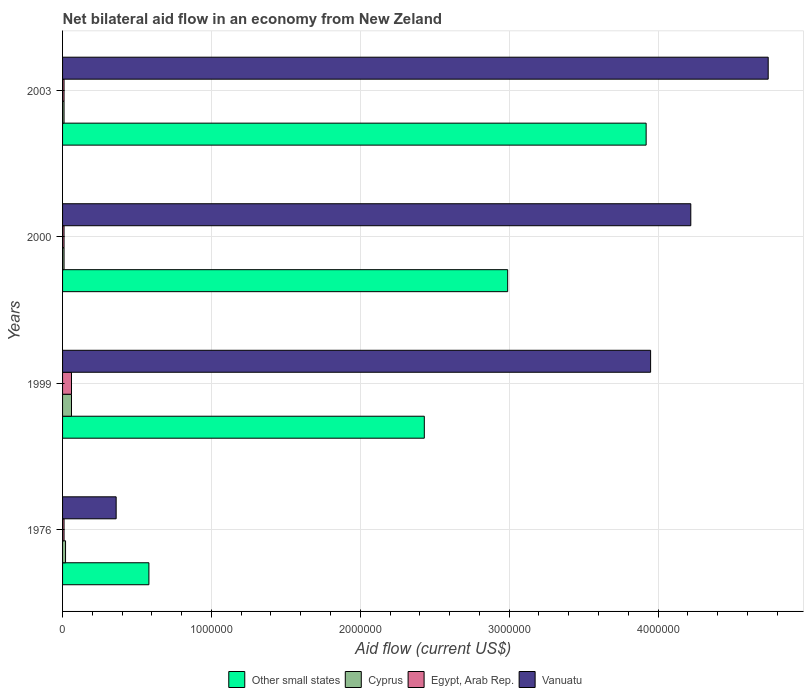How many groups of bars are there?
Provide a succinct answer. 4. Are the number of bars on each tick of the Y-axis equal?
Give a very brief answer. Yes. What is the net bilateral aid flow in Cyprus in 1976?
Provide a short and direct response. 2.00e+04. In which year was the net bilateral aid flow in Vanuatu minimum?
Provide a short and direct response. 1976. What is the difference between the net bilateral aid flow in Other small states in 1976 and that in 2003?
Your answer should be compact. -3.34e+06. What is the difference between the net bilateral aid flow in Cyprus in 1999 and the net bilateral aid flow in Other small states in 2003?
Your response must be concise. -3.86e+06. What is the average net bilateral aid flow in Cyprus per year?
Ensure brevity in your answer.  2.50e+04. In the year 2003, what is the difference between the net bilateral aid flow in Vanuatu and net bilateral aid flow in Cyprus?
Offer a very short reply. 4.73e+06. In how many years, is the net bilateral aid flow in Other small states greater than 4600000 US$?
Ensure brevity in your answer.  0. What is the ratio of the net bilateral aid flow in Egypt, Arab Rep. in 1976 to that in 1999?
Ensure brevity in your answer.  0.17. What is the difference between the highest and the second highest net bilateral aid flow in Cyprus?
Your response must be concise. 4.00e+04. What does the 3rd bar from the top in 2000 represents?
Your answer should be very brief. Cyprus. What does the 4th bar from the bottom in 2000 represents?
Offer a terse response. Vanuatu. Is it the case that in every year, the sum of the net bilateral aid flow in Egypt, Arab Rep. and net bilateral aid flow in Cyprus is greater than the net bilateral aid flow in Other small states?
Keep it short and to the point. No. How many years are there in the graph?
Keep it short and to the point. 4. What is the difference between two consecutive major ticks on the X-axis?
Ensure brevity in your answer.  1.00e+06. Are the values on the major ticks of X-axis written in scientific E-notation?
Offer a terse response. No. Does the graph contain grids?
Give a very brief answer. Yes. How are the legend labels stacked?
Your answer should be very brief. Horizontal. What is the title of the graph?
Make the answer very short. Net bilateral aid flow in an economy from New Zeland. What is the label or title of the X-axis?
Your answer should be very brief. Aid flow (current US$). What is the Aid flow (current US$) in Other small states in 1976?
Provide a succinct answer. 5.80e+05. What is the Aid flow (current US$) in Egypt, Arab Rep. in 1976?
Provide a succinct answer. 10000. What is the Aid flow (current US$) of Vanuatu in 1976?
Make the answer very short. 3.60e+05. What is the Aid flow (current US$) of Other small states in 1999?
Ensure brevity in your answer.  2.43e+06. What is the Aid flow (current US$) in Vanuatu in 1999?
Offer a terse response. 3.95e+06. What is the Aid flow (current US$) in Other small states in 2000?
Give a very brief answer. 2.99e+06. What is the Aid flow (current US$) of Cyprus in 2000?
Keep it short and to the point. 10000. What is the Aid flow (current US$) in Egypt, Arab Rep. in 2000?
Offer a terse response. 10000. What is the Aid flow (current US$) of Vanuatu in 2000?
Ensure brevity in your answer.  4.22e+06. What is the Aid flow (current US$) in Other small states in 2003?
Your answer should be compact. 3.92e+06. What is the Aid flow (current US$) of Cyprus in 2003?
Give a very brief answer. 10000. What is the Aid flow (current US$) in Egypt, Arab Rep. in 2003?
Provide a succinct answer. 10000. What is the Aid flow (current US$) in Vanuatu in 2003?
Ensure brevity in your answer.  4.74e+06. Across all years, what is the maximum Aid flow (current US$) in Other small states?
Keep it short and to the point. 3.92e+06. Across all years, what is the maximum Aid flow (current US$) of Cyprus?
Give a very brief answer. 6.00e+04. Across all years, what is the maximum Aid flow (current US$) in Vanuatu?
Make the answer very short. 4.74e+06. Across all years, what is the minimum Aid flow (current US$) in Other small states?
Ensure brevity in your answer.  5.80e+05. Across all years, what is the minimum Aid flow (current US$) in Vanuatu?
Offer a terse response. 3.60e+05. What is the total Aid flow (current US$) in Other small states in the graph?
Your response must be concise. 9.92e+06. What is the total Aid flow (current US$) in Egypt, Arab Rep. in the graph?
Make the answer very short. 9.00e+04. What is the total Aid flow (current US$) of Vanuatu in the graph?
Ensure brevity in your answer.  1.33e+07. What is the difference between the Aid flow (current US$) of Other small states in 1976 and that in 1999?
Make the answer very short. -1.85e+06. What is the difference between the Aid flow (current US$) of Vanuatu in 1976 and that in 1999?
Offer a terse response. -3.59e+06. What is the difference between the Aid flow (current US$) of Other small states in 1976 and that in 2000?
Offer a very short reply. -2.41e+06. What is the difference between the Aid flow (current US$) in Egypt, Arab Rep. in 1976 and that in 2000?
Make the answer very short. 0. What is the difference between the Aid flow (current US$) of Vanuatu in 1976 and that in 2000?
Offer a very short reply. -3.86e+06. What is the difference between the Aid flow (current US$) of Other small states in 1976 and that in 2003?
Offer a terse response. -3.34e+06. What is the difference between the Aid flow (current US$) in Egypt, Arab Rep. in 1976 and that in 2003?
Provide a succinct answer. 0. What is the difference between the Aid flow (current US$) in Vanuatu in 1976 and that in 2003?
Provide a short and direct response. -4.38e+06. What is the difference between the Aid flow (current US$) of Other small states in 1999 and that in 2000?
Your answer should be very brief. -5.60e+05. What is the difference between the Aid flow (current US$) in Vanuatu in 1999 and that in 2000?
Your answer should be very brief. -2.70e+05. What is the difference between the Aid flow (current US$) of Other small states in 1999 and that in 2003?
Your answer should be very brief. -1.49e+06. What is the difference between the Aid flow (current US$) in Egypt, Arab Rep. in 1999 and that in 2003?
Make the answer very short. 5.00e+04. What is the difference between the Aid flow (current US$) in Vanuatu in 1999 and that in 2003?
Your response must be concise. -7.90e+05. What is the difference between the Aid flow (current US$) in Other small states in 2000 and that in 2003?
Offer a terse response. -9.30e+05. What is the difference between the Aid flow (current US$) of Cyprus in 2000 and that in 2003?
Make the answer very short. 0. What is the difference between the Aid flow (current US$) in Egypt, Arab Rep. in 2000 and that in 2003?
Your answer should be very brief. 0. What is the difference between the Aid flow (current US$) of Vanuatu in 2000 and that in 2003?
Your answer should be compact. -5.20e+05. What is the difference between the Aid flow (current US$) in Other small states in 1976 and the Aid flow (current US$) in Cyprus in 1999?
Offer a terse response. 5.20e+05. What is the difference between the Aid flow (current US$) in Other small states in 1976 and the Aid flow (current US$) in Egypt, Arab Rep. in 1999?
Offer a terse response. 5.20e+05. What is the difference between the Aid flow (current US$) of Other small states in 1976 and the Aid flow (current US$) of Vanuatu in 1999?
Your response must be concise. -3.37e+06. What is the difference between the Aid flow (current US$) of Cyprus in 1976 and the Aid flow (current US$) of Vanuatu in 1999?
Offer a very short reply. -3.93e+06. What is the difference between the Aid flow (current US$) of Egypt, Arab Rep. in 1976 and the Aid flow (current US$) of Vanuatu in 1999?
Your answer should be compact. -3.94e+06. What is the difference between the Aid flow (current US$) in Other small states in 1976 and the Aid flow (current US$) in Cyprus in 2000?
Ensure brevity in your answer.  5.70e+05. What is the difference between the Aid flow (current US$) of Other small states in 1976 and the Aid flow (current US$) of Egypt, Arab Rep. in 2000?
Offer a very short reply. 5.70e+05. What is the difference between the Aid flow (current US$) of Other small states in 1976 and the Aid flow (current US$) of Vanuatu in 2000?
Give a very brief answer. -3.64e+06. What is the difference between the Aid flow (current US$) of Cyprus in 1976 and the Aid flow (current US$) of Vanuatu in 2000?
Make the answer very short. -4.20e+06. What is the difference between the Aid flow (current US$) in Egypt, Arab Rep. in 1976 and the Aid flow (current US$) in Vanuatu in 2000?
Offer a terse response. -4.21e+06. What is the difference between the Aid flow (current US$) in Other small states in 1976 and the Aid flow (current US$) in Cyprus in 2003?
Offer a terse response. 5.70e+05. What is the difference between the Aid flow (current US$) of Other small states in 1976 and the Aid flow (current US$) of Egypt, Arab Rep. in 2003?
Provide a succinct answer. 5.70e+05. What is the difference between the Aid flow (current US$) of Other small states in 1976 and the Aid flow (current US$) of Vanuatu in 2003?
Your answer should be very brief. -4.16e+06. What is the difference between the Aid flow (current US$) in Cyprus in 1976 and the Aid flow (current US$) in Vanuatu in 2003?
Ensure brevity in your answer.  -4.72e+06. What is the difference between the Aid flow (current US$) of Egypt, Arab Rep. in 1976 and the Aid flow (current US$) of Vanuatu in 2003?
Offer a very short reply. -4.73e+06. What is the difference between the Aid flow (current US$) in Other small states in 1999 and the Aid flow (current US$) in Cyprus in 2000?
Make the answer very short. 2.42e+06. What is the difference between the Aid flow (current US$) of Other small states in 1999 and the Aid flow (current US$) of Egypt, Arab Rep. in 2000?
Keep it short and to the point. 2.42e+06. What is the difference between the Aid flow (current US$) in Other small states in 1999 and the Aid flow (current US$) in Vanuatu in 2000?
Ensure brevity in your answer.  -1.79e+06. What is the difference between the Aid flow (current US$) in Cyprus in 1999 and the Aid flow (current US$) in Vanuatu in 2000?
Your response must be concise. -4.16e+06. What is the difference between the Aid flow (current US$) in Egypt, Arab Rep. in 1999 and the Aid flow (current US$) in Vanuatu in 2000?
Make the answer very short. -4.16e+06. What is the difference between the Aid flow (current US$) of Other small states in 1999 and the Aid flow (current US$) of Cyprus in 2003?
Your response must be concise. 2.42e+06. What is the difference between the Aid flow (current US$) in Other small states in 1999 and the Aid flow (current US$) in Egypt, Arab Rep. in 2003?
Make the answer very short. 2.42e+06. What is the difference between the Aid flow (current US$) of Other small states in 1999 and the Aid flow (current US$) of Vanuatu in 2003?
Offer a very short reply. -2.31e+06. What is the difference between the Aid flow (current US$) of Cyprus in 1999 and the Aid flow (current US$) of Vanuatu in 2003?
Ensure brevity in your answer.  -4.68e+06. What is the difference between the Aid flow (current US$) of Egypt, Arab Rep. in 1999 and the Aid flow (current US$) of Vanuatu in 2003?
Give a very brief answer. -4.68e+06. What is the difference between the Aid flow (current US$) of Other small states in 2000 and the Aid flow (current US$) of Cyprus in 2003?
Make the answer very short. 2.98e+06. What is the difference between the Aid flow (current US$) of Other small states in 2000 and the Aid flow (current US$) of Egypt, Arab Rep. in 2003?
Offer a very short reply. 2.98e+06. What is the difference between the Aid flow (current US$) of Other small states in 2000 and the Aid flow (current US$) of Vanuatu in 2003?
Your response must be concise. -1.75e+06. What is the difference between the Aid flow (current US$) of Cyprus in 2000 and the Aid flow (current US$) of Vanuatu in 2003?
Offer a very short reply. -4.73e+06. What is the difference between the Aid flow (current US$) in Egypt, Arab Rep. in 2000 and the Aid flow (current US$) in Vanuatu in 2003?
Make the answer very short. -4.73e+06. What is the average Aid flow (current US$) in Other small states per year?
Ensure brevity in your answer.  2.48e+06. What is the average Aid flow (current US$) in Cyprus per year?
Offer a very short reply. 2.50e+04. What is the average Aid flow (current US$) in Egypt, Arab Rep. per year?
Your answer should be very brief. 2.25e+04. What is the average Aid flow (current US$) of Vanuatu per year?
Your answer should be compact. 3.32e+06. In the year 1976, what is the difference between the Aid flow (current US$) of Other small states and Aid flow (current US$) of Cyprus?
Your answer should be compact. 5.60e+05. In the year 1976, what is the difference between the Aid flow (current US$) of Other small states and Aid flow (current US$) of Egypt, Arab Rep.?
Provide a succinct answer. 5.70e+05. In the year 1976, what is the difference between the Aid flow (current US$) of Cyprus and Aid flow (current US$) of Egypt, Arab Rep.?
Make the answer very short. 10000. In the year 1976, what is the difference between the Aid flow (current US$) in Cyprus and Aid flow (current US$) in Vanuatu?
Your answer should be very brief. -3.40e+05. In the year 1976, what is the difference between the Aid flow (current US$) of Egypt, Arab Rep. and Aid flow (current US$) of Vanuatu?
Offer a very short reply. -3.50e+05. In the year 1999, what is the difference between the Aid flow (current US$) in Other small states and Aid flow (current US$) in Cyprus?
Make the answer very short. 2.37e+06. In the year 1999, what is the difference between the Aid flow (current US$) of Other small states and Aid flow (current US$) of Egypt, Arab Rep.?
Offer a terse response. 2.37e+06. In the year 1999, what is the difference between the Aid flow (current US$) in Other small states and Aid flow (current US$) in Vanuatu?
Keep it short and to the point. -1.52e+06. In the year 1999, what is the difference between the Aid flow (current US$) in Cyprus and Aid flow (current US$) in Egypt, Arab Rep.?
Your answer should be very brief. 0. In the year 1999, what is the difference between the Aid flow (current US$) of Cyprus and Aid flow (current US$) of Vanuatu?
Your response must be concise. -3.89e+06. In the year 1999, what is the difference between the Aid flow (current US$) of Egypt, Arab Rep. and Aid flow (current US$) of Vanuatu?
Give a very brief answer. -3.89e+06. In the year 2000, what is the difference between the Aid flow (current US$) in Other small states and Aid flow (current US$) in Cyprus?
Give a very brief answer. 2.98e+06. In the year 2000, what is the difference between the Aid flow (current US$) of Other small states and Aid flow (current US$) of Egypt, Arab Rep.?
Your response must be concise. 2.98e+06. In the year 2000, what is the difference between the Aid flow (current US$) of Other small states and Aid flow (current US$) of Vanuatu?
Offer a terse response. -1.23e+06. In the year 2000, what is the difference between the Aid flow (current US$) of Cyprus and Aid flow (current US$) of Vanuatu?
Your answer should be compact. -4.21e+06. In the year 2000, what is the difference between the Aid flow (current US$) in Egypt, Arab Rep. and Aid flow (current US$) in Vanuatu?
Keep it short and to the point. -4.21e+06. In the year 2003, what is the difference between the Aid flow (current US$) in Other small states and Aid flow (current US$) in Cyprus?
Keep it short and to the point. 3.91e+06. In the year 2003, what is the difference between the Aid flow (current US$) of Other small states and Aid flow (current US$) of Egypt, Arab Rep.?
Give a very brief answer. 3.91e+06. In the year 2003, what is the difference between the Aid flow (current US$) in Other small states and Aid flow (current US$) in Vanuatu?
Your response must be concise. -8.20e+05. In the year 2003, what is the difference between the Aid flow (current US$) in Cyprus and Aid flow (current US$) in Egypt, Arab Rep.?
Your answer should be compact. 0. In the year 2003, what is the difference between the Aid flow (current US$) in Cyprus and Aid flow (current US$) in Vanuatu?
Give a very brief answer. -4.73e+06. In the year 2003, what is the difference between the Aid flow (current US$) in Egypt, Arab Rep. and Aid flow (current US$) in Vanuatu?
Give a very brief answer. -4.73e+06. What is the ratio of the Aid flow (current US$) of Other small states in 1976 to that in 1999?
Your answer should be compact. 0.24. What is the ratio of the Aid flow (current US$) in Cyprus in 1976 to that in 1999?
Give a very brief answer. 0.33. What is the ratio of the Aid flow (current US$) in Vanuatu in 1976 to that in 1999?
Your answer should be compact. 0.09. What is the ratio of the Aid flow (current US$) in Other small states in 1976 to that in 2000?
Give a very brief answer. 0.19. What is the ratio of the Aid flow (current US$) of Cyprus in 1976 to that in 2000?
Your answer should be compact. 2. What is the ratio of the Aid flow (current US$) of Vanuatu in 1976 to that in 2000?
Give a very brief answer. 0.09. What is the ratio of the Aid flow (current US$) in Other small states in 1976 to that in 2003?
Give a very brief answer. 0.15. What is the ratio of the Aid flow (current US$) of Vanuatu in 1976 to that in 2003?
Your answer should be very brief. 0.08. What is the ratio of the Aid flow (current US$) of Other small states in 1999 to that in 2000?
Give a very brief answer. 0.81. What is the ratio of the Aid flow (current US$) in Cyprus in 1999 to that in 2000?
Provide a succinct answer. 6. What is the ratio of the Aid flow (current US$) in Vanuatu in 1999 to that in 2000?
Offer a very short reply. 0.94. What is the ratio of the Aid flow (current US$) of Other small states in 1999 to that in 2003?
Provide a succinct answer. 0.62. What is the ratio of the Aid flow (current US$) in Other small states in 2000 to that in 2003?
Offer a terse response. 0.76. What is the ratio of the Aid flow (current US$) in Cyprus in 2000 to that in 2003?
Provide a short and direct response. 1. What is the ratio of the Aid flow (current US$) in Egypt, Arab Rep. in 2000 to that in 2003?
Ensure brevity in your answer.  1. What is the ratio of the Aid flow (current US$) of Vanuatu in 2000 to that in 2003?
Your answer should be very brief. 0.89. What is the difference between the highest and the second highest Aid flow (current US$) in Other small states?
Your response must be concise. 9.30e+05. What is the difference between the highest and the second highest Aid flow (current US$) in Egypt, Arab Rep.?
Provide a succinct answer. 5.00e+04. What is the difference between the highest and the second highest Aid flow (current US$) of Vanuatu?
Your response must be concise. 5.20e+05. What is the difference between the highest and the lowest Aid flow (current US$) in Other small states?
Your answer should be very brief. 3.34e+06. What is the difference between the highest and the lowest Aid flow (current US$) in Cyprus?
Ensure brevity in your answer.  5.00e+04. What is the difference between the highest and the lowest Aid flow (current US$) of Vanuatu?
Provide a short and direct response. 4.38e+06. 